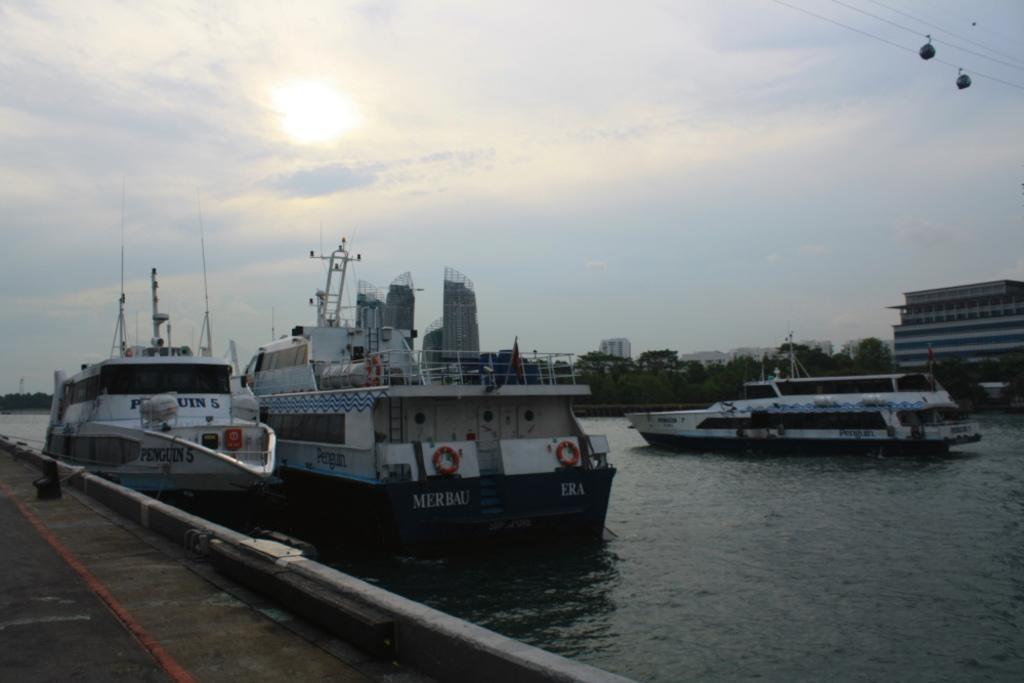Can you describe this image briefly? On the left there is a road and there are ships on the water. In the background there are buildings,trees and clouds in the sky. On the right at the top there are two cable cars. 